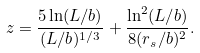Convert formula to latex. <formula><loc_0><loc_0><loc_500><loc_500>z = \frac { 5 \ln ( L / b ) } { ( L / b ) ^ { 1 / 3 } } + \frac { \ln ^ { 2 } ( L / b ) } { 8 ( r _ { s } / b ) ^ { 2 } } .</formula> 